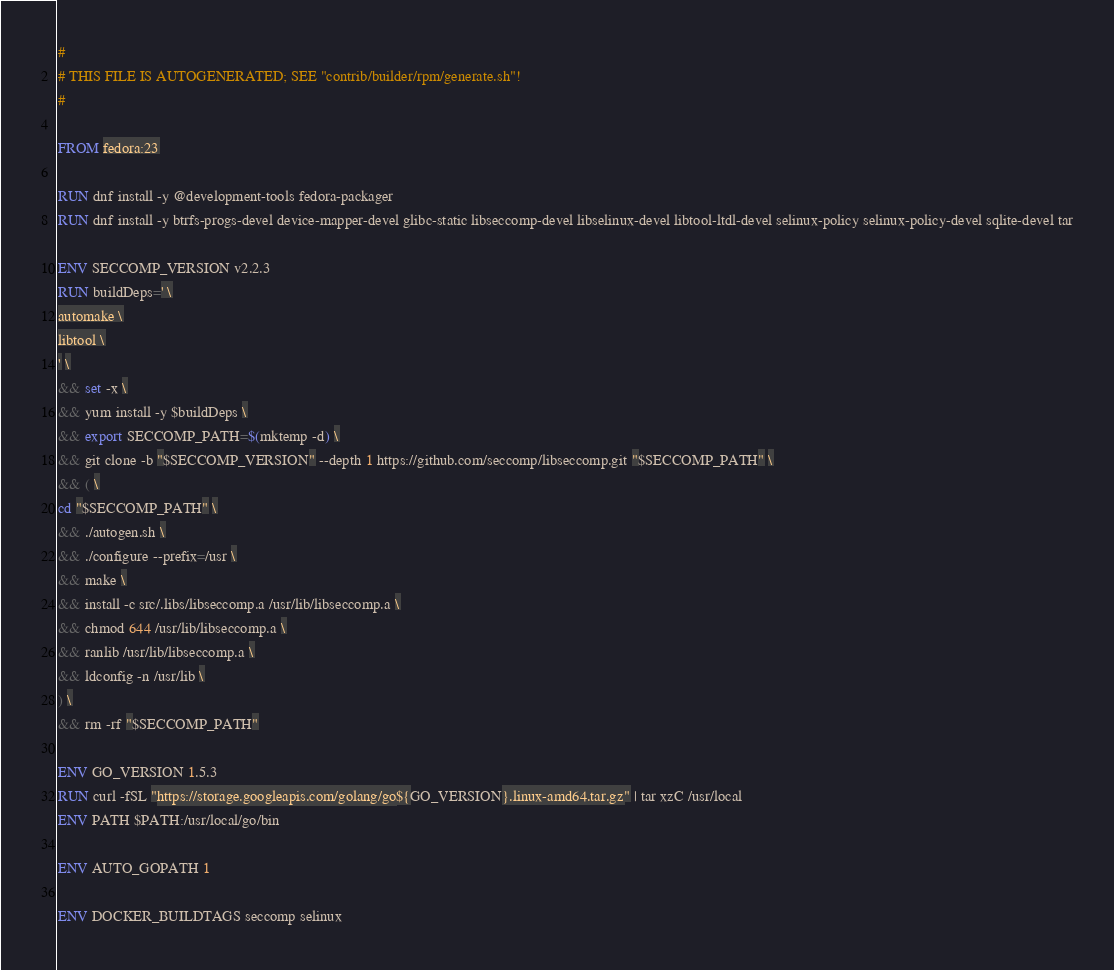Convert code to text. <code><loc_0><loc_0><loc_500><loc_500><_Dockerfile_>#
# THIS FILE IS AUTOGENERATED; SEE "contrib/builder/rpm/generate.sh"!
#

FROM fedora:23

RUN dnf install -y @development-tools fedora-packager
RUN dnf install -y btrfs-progs-devel device-mapper-devel glibc-static libseccomp-devel libselinux-devel libtool-ltdl-devel selinux-policy selinux-policy-devel sqlite-devel tar

ENV SECCOMP_VERSION v2.2.3
RUN buildDeps=' \
automake \
libtool \
' \
&& set -x \
&& yum install -y $buildDeps \
&& export SECCOMP_PATH=$(mktemp -d) \
&& git clone -b "$SECCOMP_VERSION" --depth 1 https://github.com/seccomp/libseccomp.git "$SECCOMP_PATH" \
&& ( \
cd "$SECCOMP_PATH" \
&& ./autogen.sh \
&& ./configure --prefix=/usr \
&& make \
&& install -c src/.libs/libseccomp.a /usr/lib/libseccomp.a \
&& chmod 644 /usr/lib/libseccomp.a \
&& ranlib /usr/lib/libseccomp.a \
&& ldconfig -n /usr/lib \
) \
&& rm -rf "$SECCOMP_PATH"

ENV GO_VERSION 1.5.3
RUN curl -fSL "https://storage.googleapis.com/golang/go${GO_VERSION}.linux-amd64.tar.gz" | tar xzC /usr/local
ENV PATH $PATH:/usr/local/go/bin

ENV AUTO_GOPATH 1

ENV DOCKER_BUILDTAGS seccomp selinux
</code> 